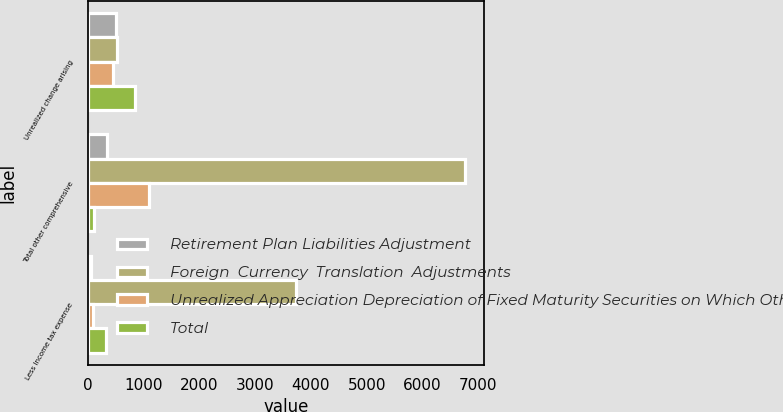Convert chart. <chart><loc_0><loc_0><loc_500><loc_500><stacked_bar_chart><ecel><fcel>Unrealized change arising<fcel>Total other comprehensive<fcel>Less Income tax expense<nl><fcel>Retirement Plan Liabilities Adjustment<fcel>507<fcel>347<fcel>55<nl><fcel>Foreign  Currency  Translation  Adjustments<fcel>524.5<fcel>6762<fcel>3738<nl><fcel>Unrealized Appreciation Depreciation of Fixed Maturity Securities on Which OtherThan Temporary Credit Impairments Were Recognized<fcel>454<fcel>1100<fcel>102<nl><fcel>Total<fcel>851<fcel>123<fcel>330<nl></chart> 